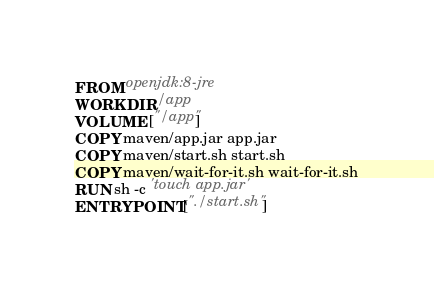Convert code to text. <code><loc_0><loc_0><loc_500><loc_500><_Dockerfile_>FROM openjdk:8-jre
WORKDIR /app
VOLUME ["/app"]
COPY maven/app.jar app.jar
COPY maven/start.sh start.sh
COPY maven/wait-for-it.sh wait-for-it.sh
RUN sh -c 'touch app.jar'
ENTRYPOINT ["./start.sh"]
</code> 